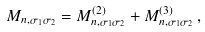Convert formula to latex. <formula><loc_0><loc_0><loc_500><loc_500>M _ { n , \sigma _ { 1 } \sigma _ { 2 } } = M ^ { ( 2 ) } _ { n , \sigma _ { 1 } \sigma _ { 2 } } + M ^ { ( 3 ) } _ { n , \sigma _ { 1 } \sigma _ { 2 } } \, ,</formula> 